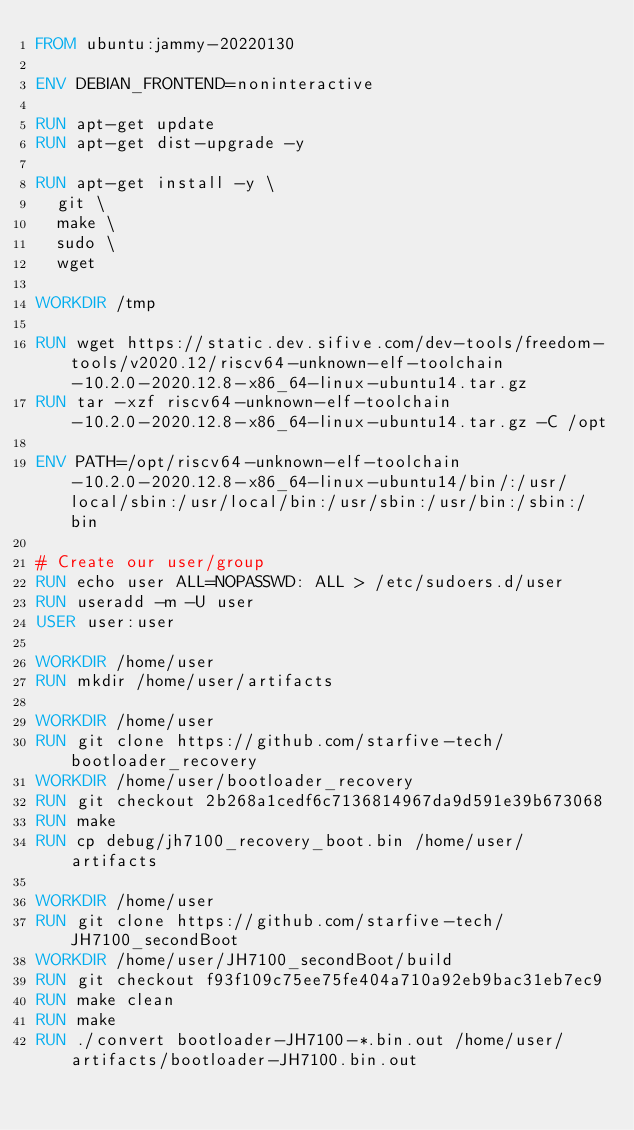<code> <loc_0><loc_0><loc_500><loc_500><_Dockerfile_>FROM ubuntu:jammy-20220130

ENV DEBIAN_FRONTEND=noninteractive

RUN apt-get update
RUN apt-get dist-upgrade -y

RUN apt-get install -y \
	git \
	make \
	sudo \
	wget

WORKDIR /tmp

RUN wget https://static.dev.sifive.com/dev-tools/freedom-tools/v2020.12/riscv64-unknown-elf-toolchain-10.2.0-2020.12.8-x86_64-linux-ubuntu14.tar.gz
RUN tar -xzf riscv64-unknown-elf-toolchain-10.2.0-2020.12.8-x86_64-linux-ubuntu14.tar.gz -C /opt

ENV PATH=/opt/riscv64-unknown-elf-toolchain-10.2.0-2020.12.8-x86_64-linux-ubuntu14/bin/:/usr/local/sbin:/usr/local/bin:/usr/sbin:/usr/bin:/sbin:/bin

# Create our user/group
RUN echo user ALL=NOPASSWD: ALL > /etc/sudoers.d/user
RUN useradd -m -U user
USER user:user

WORKDIR /home/user
RUN mkdir /home/user/artifacts

WORKDIR /home/user
RUN git clone https://github.com/starfive-tech/bootloader_recovery
WORKDIR /home/user/bootloader_recovery
RUN git checkout 2b268a1cedf6c7136814967da9d591e39b673068
RUN make
RUN cp debug/jh7100_recovery_boot.bin /home/user/artifacts

WORKDIR /home/user
RUN git clone https://github.com/starfive-tech/JH7100_secondBoot
WORKDIR /home/user/JH7100_secondBoot/build
RUN git checkout f93f109c75ee75fe404a710a92eb9bac31eb7ec9
RUN make clean
RUN make
RUN ./convert bootloader-JH7100-*.bin.out /home/user/artifacts/bootloader-JH7100.bin.out
</code> 